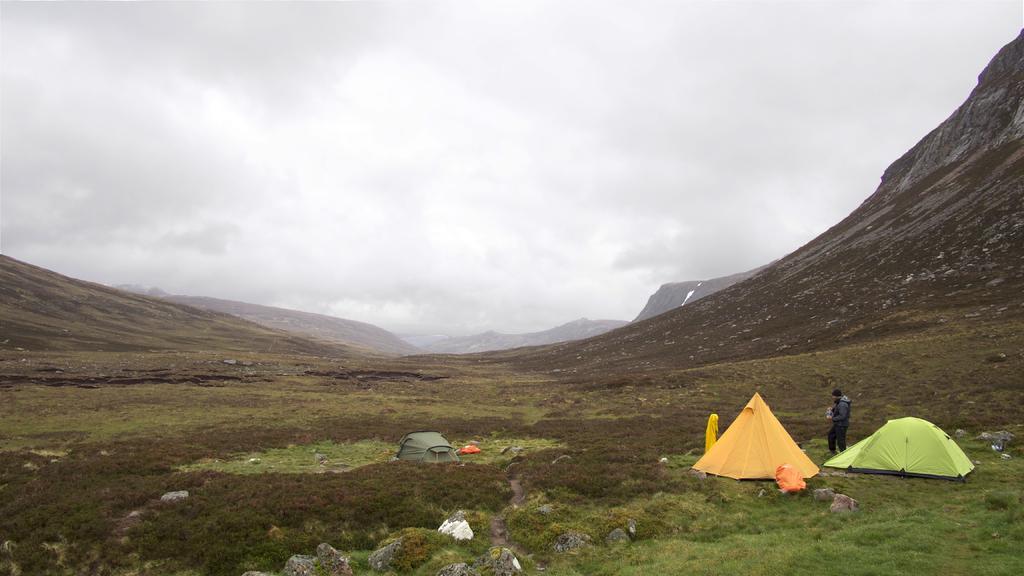In one or two sentences, can you explain what this image depicts? As we can see in the image there is a man, tents, grass and hill. On the top there is a sky. 